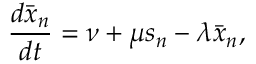Convert formula to latex. <formula><loc_0><loc_0><loc_500><loc_500>\frac { d \bar { x } _ { n } } { d t } = \nu + \mu s _ { n } - \lambda \bar { x } _ { n } ,</formula> 